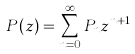Convert formula to latex. <formula><loc_0><loc_0><loc_500><loc_500>P ( z ) = \sum _ { n = 0 } ^ { \infty } { P _ { n } } z ^ { n + 1 }</formula> 